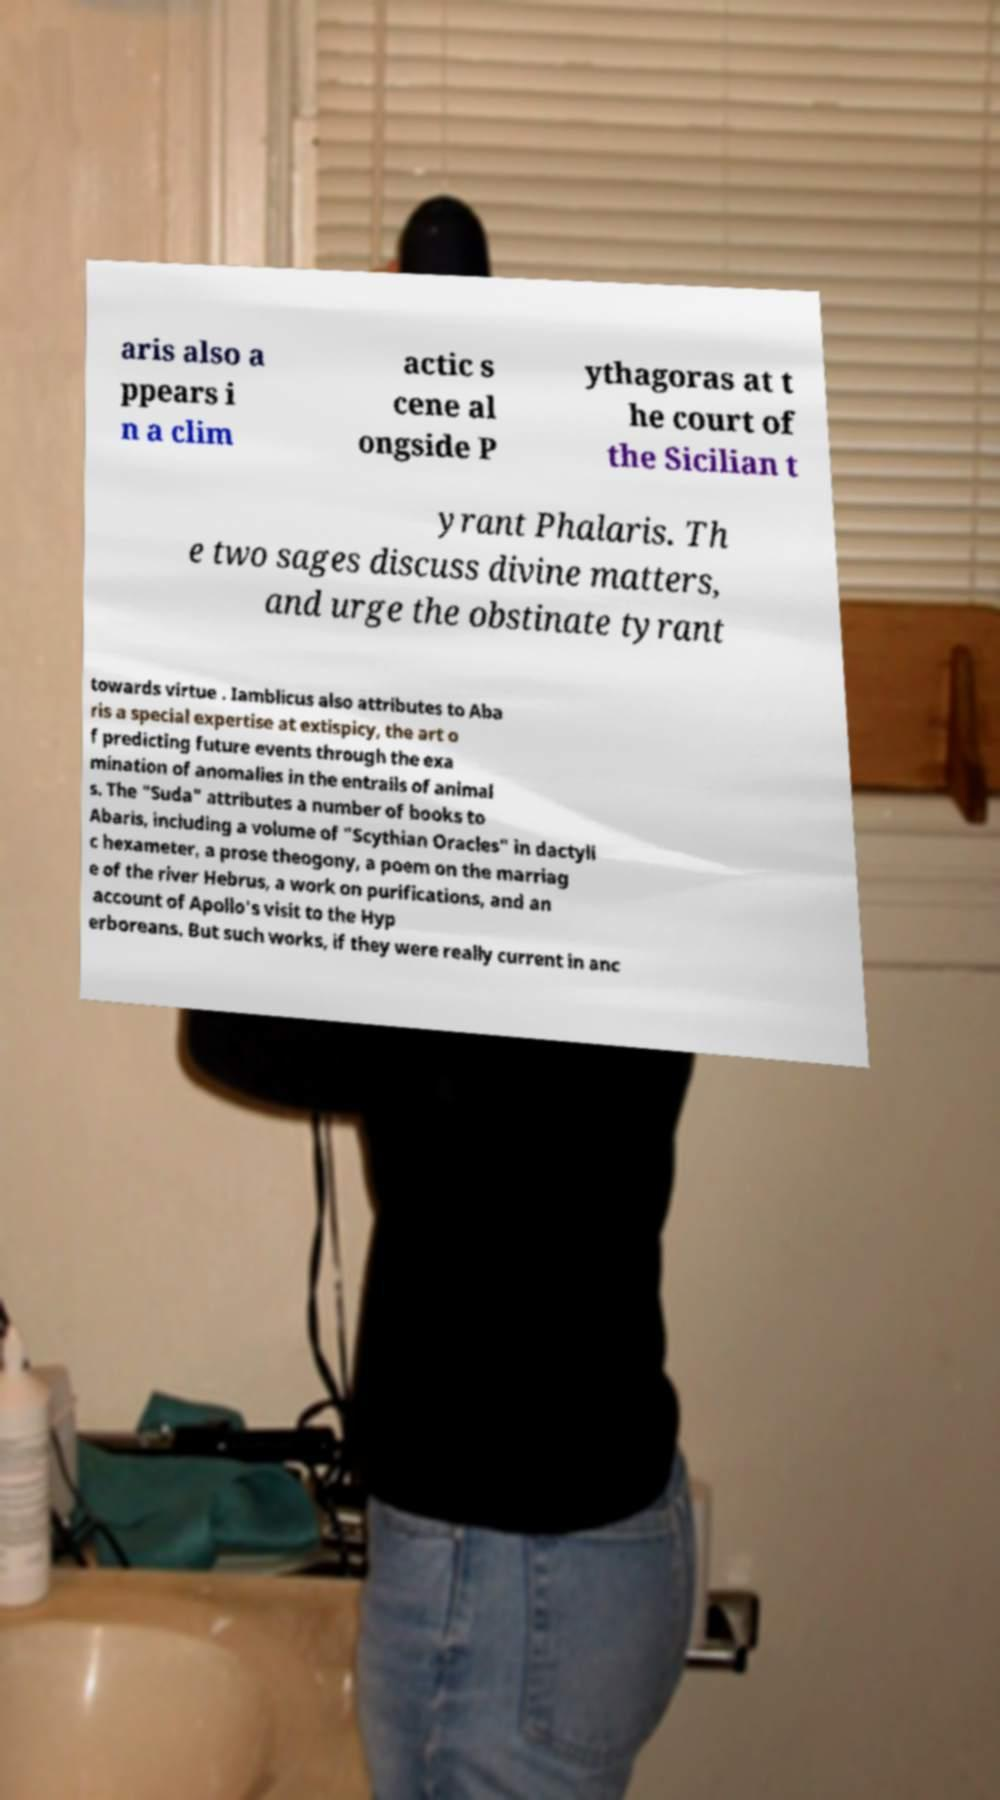I need the written content from this picture converted into text. Can you do that? aris also a ppears i n a clim actic s cene al ongside P ythagoras at t he court of the Sicilian t yrant Phalaris. Th e two sages discuss divine matters, and urge the obstinate tyrant towards virtue . Iamblicus also attributes to Aba ris a special expertise at extispicy, the art o f predicting future events through the exa mination of anomalies in the entrails of animal s. The "Suda" attributes a number of books to Abaris, including a volume of "Scythian Oracles" in dactyli c hexameter, a prose theogony, a poem on the marriag e of the river Hebrus, a work on purifications, and an account of Apollo's visit to the Hyp erboreans. But such works, if they were really current in anc 